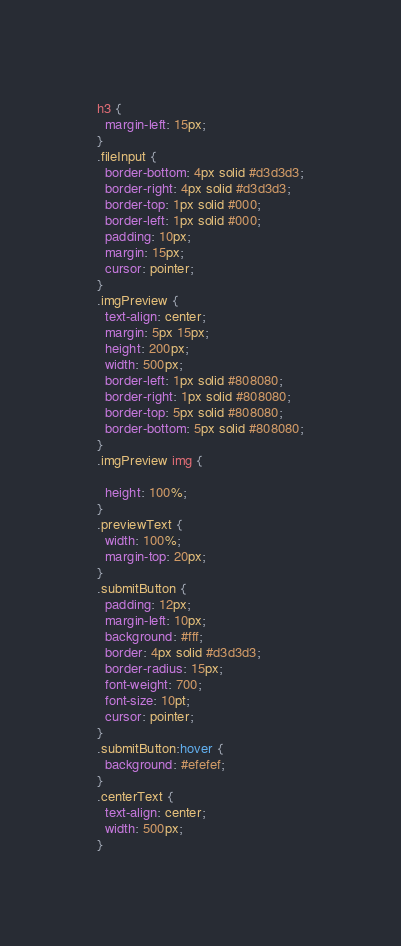Convert code to text. <code><loc_0><loc_0><loc_500><loc_500><_CSS_>h3 {
  margin-left: 15px;
}
.fileInput {
  border-bottom: 4px solid #d3d3d3;
  border-right: 4px solid #d3d3d3;
  border-top: 1px solid #000;
  border-left: 1px solid #000;
  padding: 10px;
  margin: 15px;
  cursor: pointer;
}
.imgPreview {
  text-align: center;
  margin: 5px 15px;
  height: 200px;
  width: 500px;
  border-left: 1px solid #808080;
  border-right: 1px solid #808080;
  border-top: 5px solid #808080;
  border-bottom: 5px solid #808080;
}
.imgPreview img {

  height: 100%;
}
.previewText {
  width: 100%;
  margin-top: 20px;
}
.submitButton {
  padding: 12px;
  margin-left: 10px;
  background: #fff;
  border: 4px solid #d3d3d3;
  border-radius: 15px;
  font-weight: 700;
  font-size: 10pt;
  cursor: pointer;
}
.submitButton:hover {
  background: #efefef;
}
.centerText {
  text-align: center;
  width: 500px;
}
</code> 